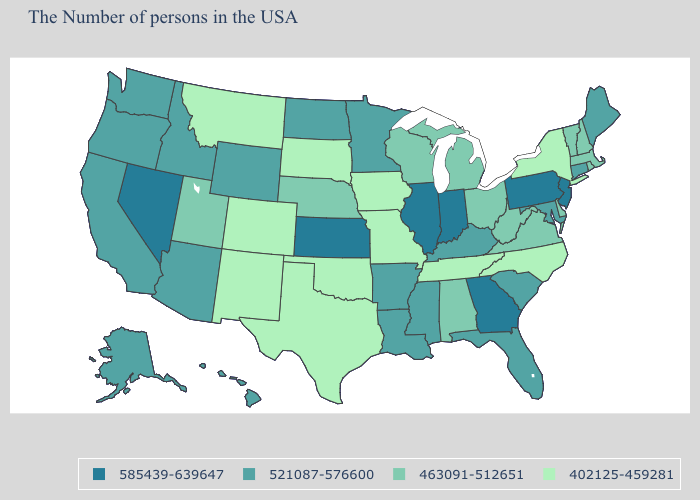Is the legend a continuous bar?
Be succinct. No. Name the states that have a value in the range 521087-576600?
Quick response, please. Maine, Connecticut, Maryland, South Carolina, Florida, Kentucky, Mississippi, Louisiana, Arkansas, Minnesota, North Dakota, Wyoming, Arizona, Idaho, California, Washington, Oregon, Alaska, Hawaii. What is the lowest value in states that border New York?
Give a very brief answer. 463091-512651. Which states hav the highest value in the MidWest?
Short answer required. Indiana, Illinois, Kansas. Among the states that border Rhode Island , does Connecticut have the lowest value?
Give a very brief answer. No. Name the states that have a value in the range 585439-639647?
Keep it brief. New Jersey, Pennsylvania, Georgia, Indiana, Illinois, Kansas, Nevada. What is the value of Oregon?
Quick response, please. 521087-576600. Name the states that have a value in the range 585439-639647?
Write a very short answer. New Jersey, Pennsylvania, Georgia, Indiana, Illinois, Kansas, Nevada. Which states hav the highest value in the West?
Keep it brief. Nevada. What is the value of Tennessee?
Give a very brief answer. 402125-459281. Which states hav the highest value in the MidWest?
Write a very short answer. Indiana, Illinois, Kansas. Name the states that have a value in the range 521087-576600?
Concise answer only. Maine, Connecticut, Maryland, South Carolina, Florida, Kentucky, Mississippi, Louisiana, Arkansas, Minnesota, North Dakota, Wyoming, Arizona, Idaho, California, Washington, Oregon, Alaska, Hawaii. Name the states that have a value in the range 521087-576600?
Write a very short answer. Maine, Connecticut, Maryland, South Carolina, Florida, Kentucky, Mississippi, Louisiana, Arkansas, Minnesota, North Dakota, Wyoming, Arizona, Idaho, California, Washington, Oregon, Alaska, Hawaii. Which states have the highest value in the USA?
Answer briefly. New Jersey, Pennsylvania, Georgia, Indiana, Illinois, Kansas, Nevada. What is the value of Missouri?
Concise answer only. 402125-459281. 